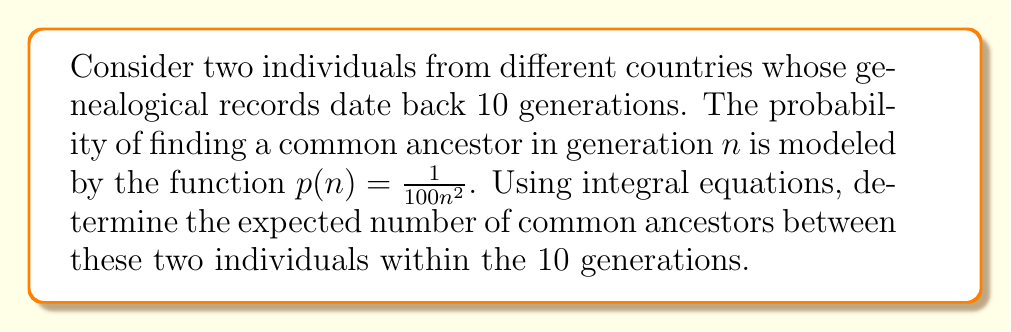Can you solve this math problem? To solve this problem, we'll follow these steps:

1) The expected number of common ancestors can be calculated by summing the probabilities for each generation. Since we're dealing with a continuous function, we'll use an integral.

2) The integral equation for the expected number of common ancestors (E) is:

   $$E = \int_1^{10} p(n) dn$$

3) Substituting our probability function:

   $$E = \int_1^{10} \frac{1}{100n^2} dn$$

4) To solve this integral, we'll use the power rule of integration:

   $$E = \frac{1}{100} \int_1^{10} \frac{1}{n^2} dn = \frac{1}{100} \left[-\frac{1}{n}\right]_1^{10}$$

5) Evaluating the integral:

   $$E = \frac{1}{100} \left[-\frac{1}{10} - \left(-1\right)\right] = \frac{1}{100} \left(1 - \frac{1}{10}\right)$$

6) Simplifying:

   $$E = \frac{1}{100} \cdot \frac{9}{10} = \frac{9}{1000} = 0.009$$

Therefore, the expected number of common ancestors within 10 generations is 0.009.
Answer: 0.009 